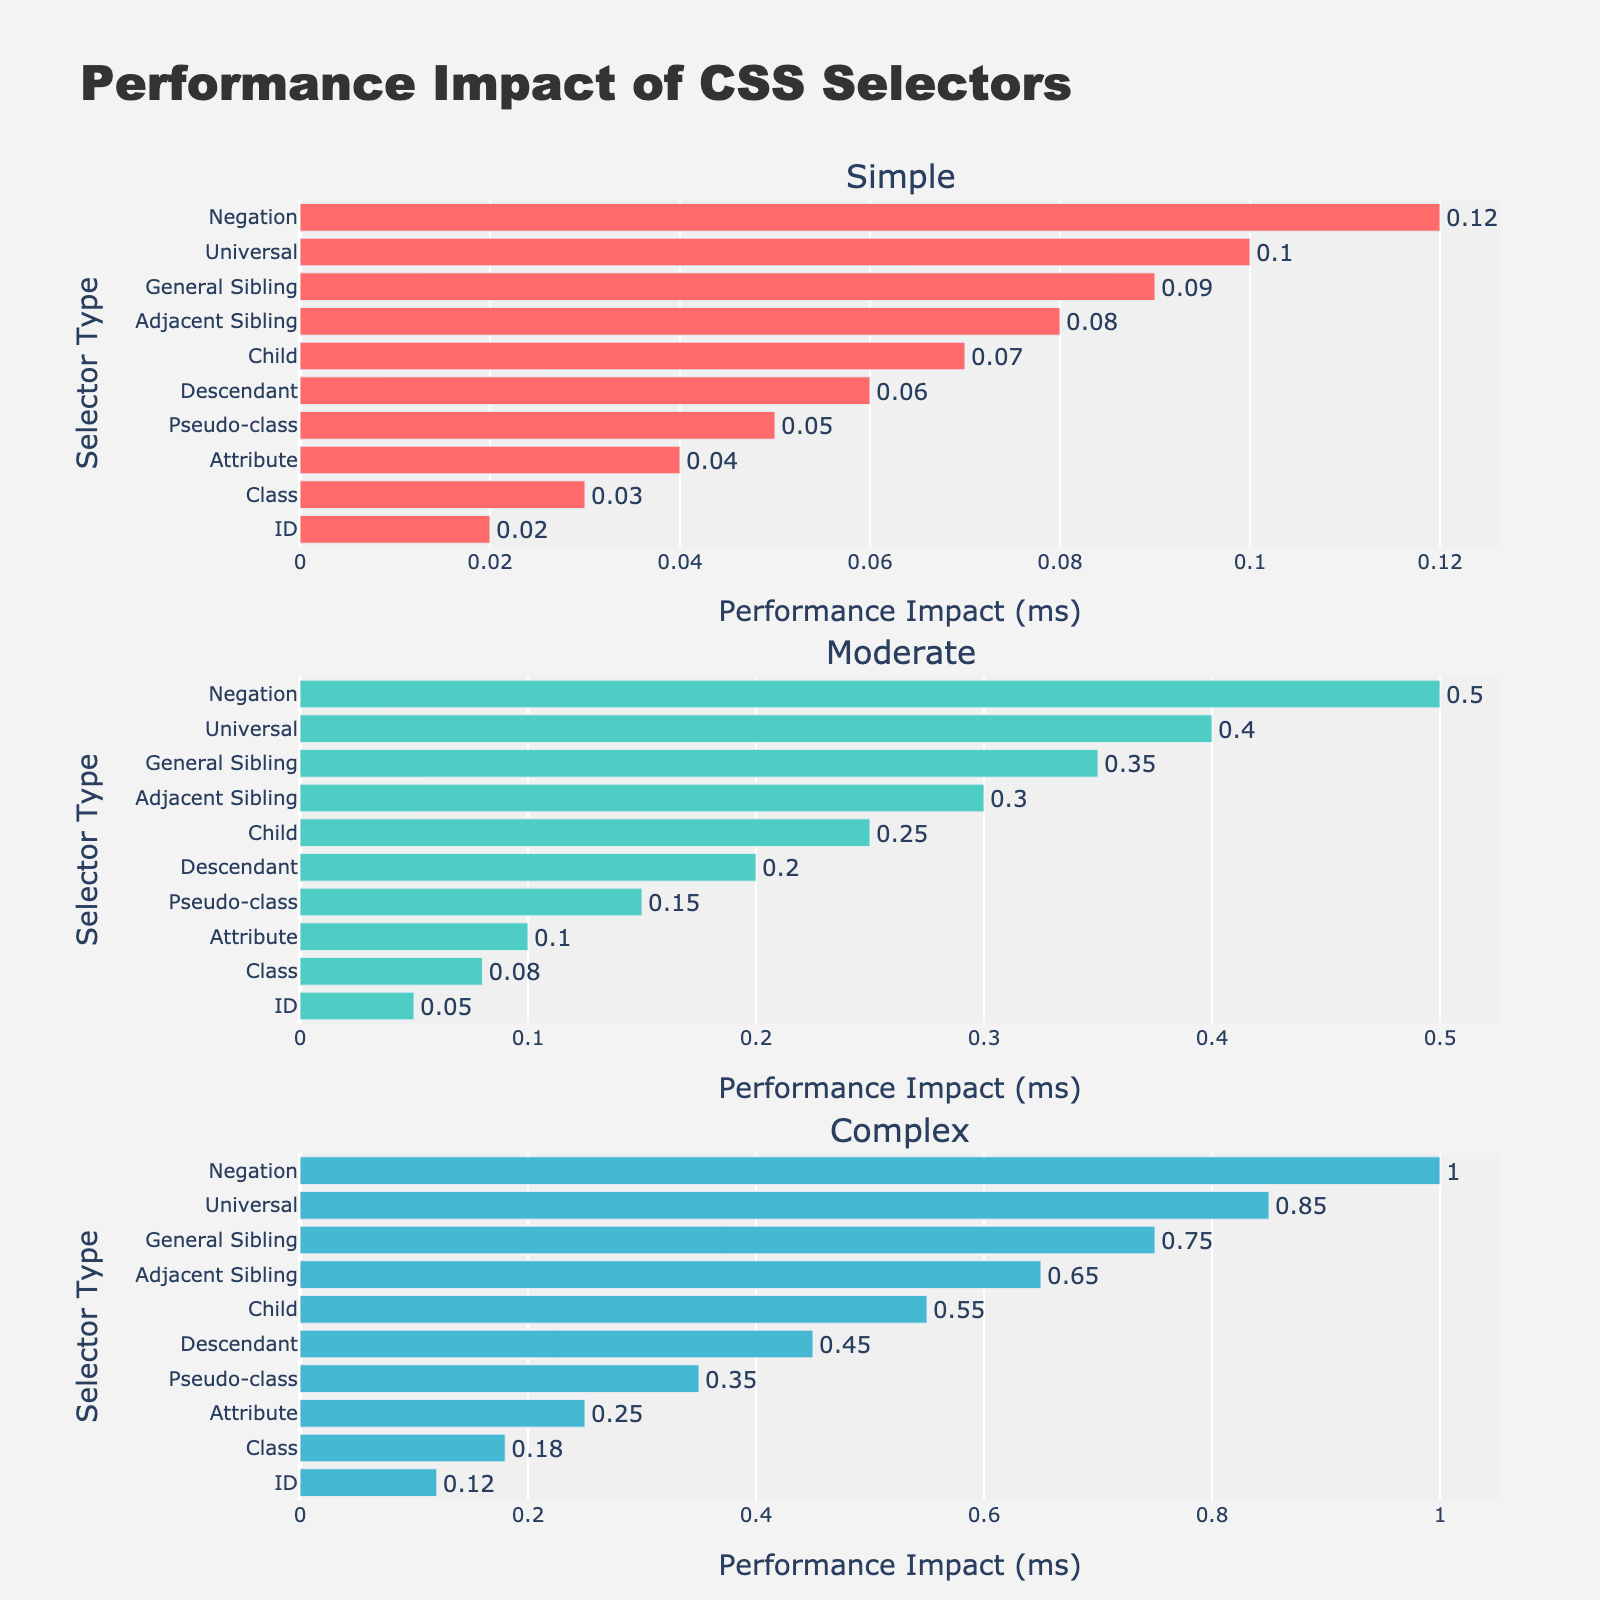What is the title of the plot? The title is located at the top center of the plot and reads "Trend of Funding Allocation for Music Programs (2018-2022)".
Answer: Trend of Funding Allocation for Music Programs (2018-2022) Which school shows the highest funding allocation in 2018? Observe the first subplot for 2018 data, where the funding for Juilliard School is the highest at 42.8 million USD.
Answer: Juilliard School How many schools are tracked in the plot? Count the number of subplot titles or the rows in the figure. There are 5 different schools represented.
Answer: 5 What is the funding trend for UNCSA from 2018 to 2022? Examine the first subplot and observe the line trend from 2018 to 2022. UNCSA funding starts at 15.2 million in 2018, increases slightly to 16.1 million in 2019, dips to 15.8 million in 2020, drops further to 14.9 million in 2021, and finally rises to 15.5 million in 2022.
Answer: Fluctuating with a slight upward trend Which year saw the lowest funding for the Curtis Institute of Music? Look at the Curtis Institute of Music subplot. The lowest funding occurs in 2021, with 17.8 million USD.
Answer: 2021 How does the funding allocation for Oberlin Conservatory compare between 2018 and 2022? Examine the Oberlin Conservatory subplot and compare the values. In 2018, the funding was 22.3 million USD, and in 2022, it was 21.2 million USD, showing a slight decrease.
Answer: Decreased What's the average funding allocation for Eastman School of Music over the 5-year period? Sum the funding amounts for 2018 to 2022 (31.6 + 32.1 + 30.5 + 29.7 + 30.9) and divide by 5. The total is 154.8 million USD, so the average is 154.8/5.
Answer: 30.96 million USD Did the funding allocation for Juilliard School ever decrease between consecutive years? Examine the Juilliard School's subplot. The only decrease is from 2019 (43.5 million) to 2020 (41.9 million).
Answer: Yes, from 2019 to 2020 Which school had the most consistent funding allocation over the years? Calculate the variance in funding for each school by examining the subplots' trends. Oberlin Conservatory shows the most consistent funding, with values ranging narrowly from 22.3 to 21.2 million USD over the five years.
Answer: Oberlin Conservatory 